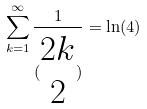<formula> <loc_0><loc_0><loc_500><loc_500>\sum _ { k = 1 } ^ { \infty } \frac { 1 } { ( \begin{matrix} 2 k \\ 2 \end{matrix} ) } = \ln ( 4 )</formula> 